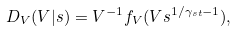Convert formula to latex. <formula><loc_0><loc_0><loc_500><loc_500>D _ { V } ( V | s ) = V ^ { - 1 } f _ { V } ( V s ^ { 1 / \gamma _ { s t } - 1 } ) ,</formula> 